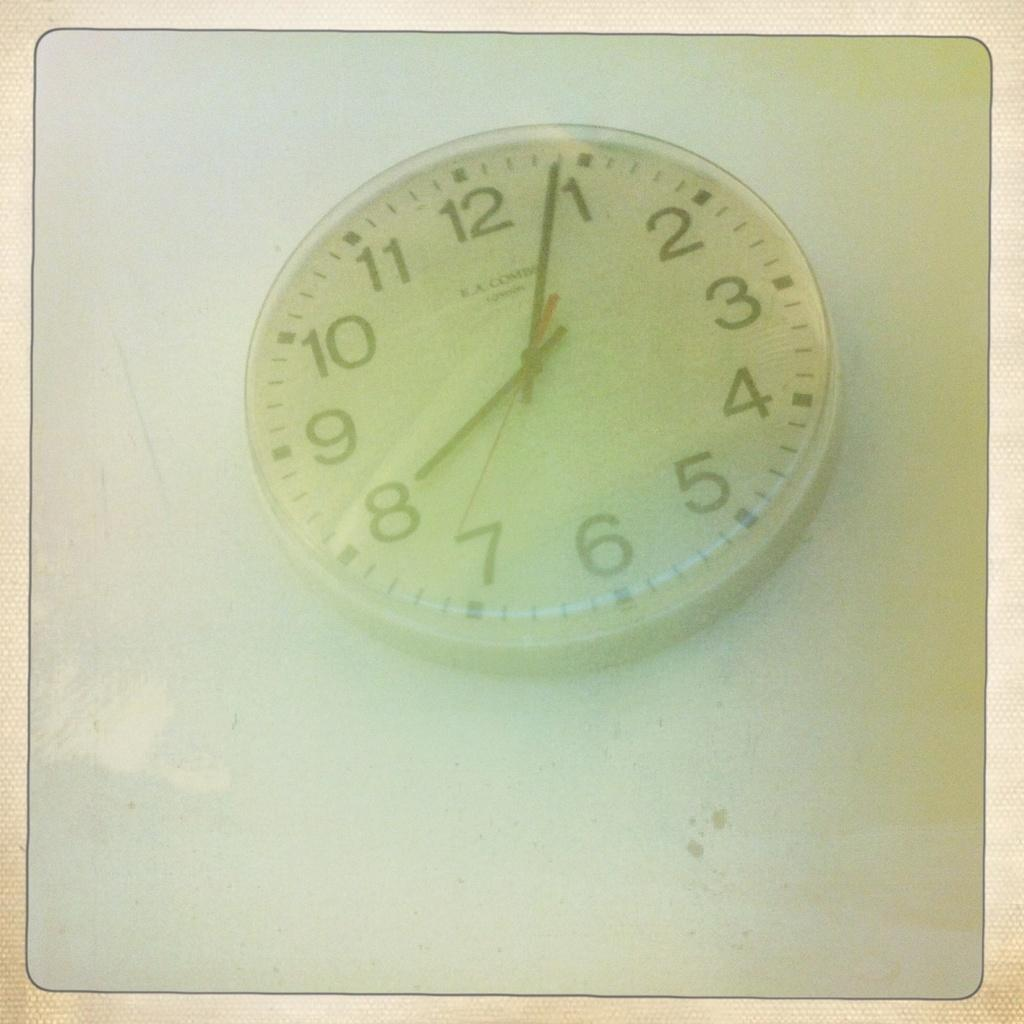Provide a one-sentence caption for the provided image. Clock that says eight o four laying flat down. 